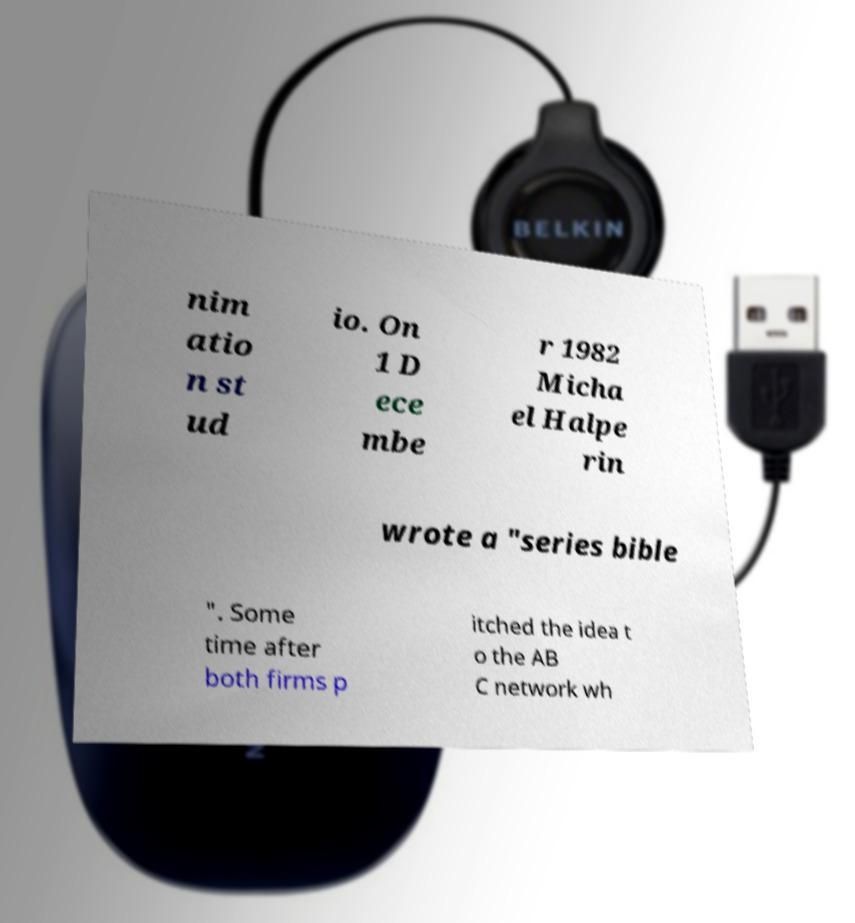There's text embedded in this image that I need extracted. Can you transcribe it verbatim? nim atio n st ud io. On 1 D ece mbe r 1982 Micha el Halpe rin wrote a "series bible ". Some time after both firms p itched the idea t o the AB C network wh 